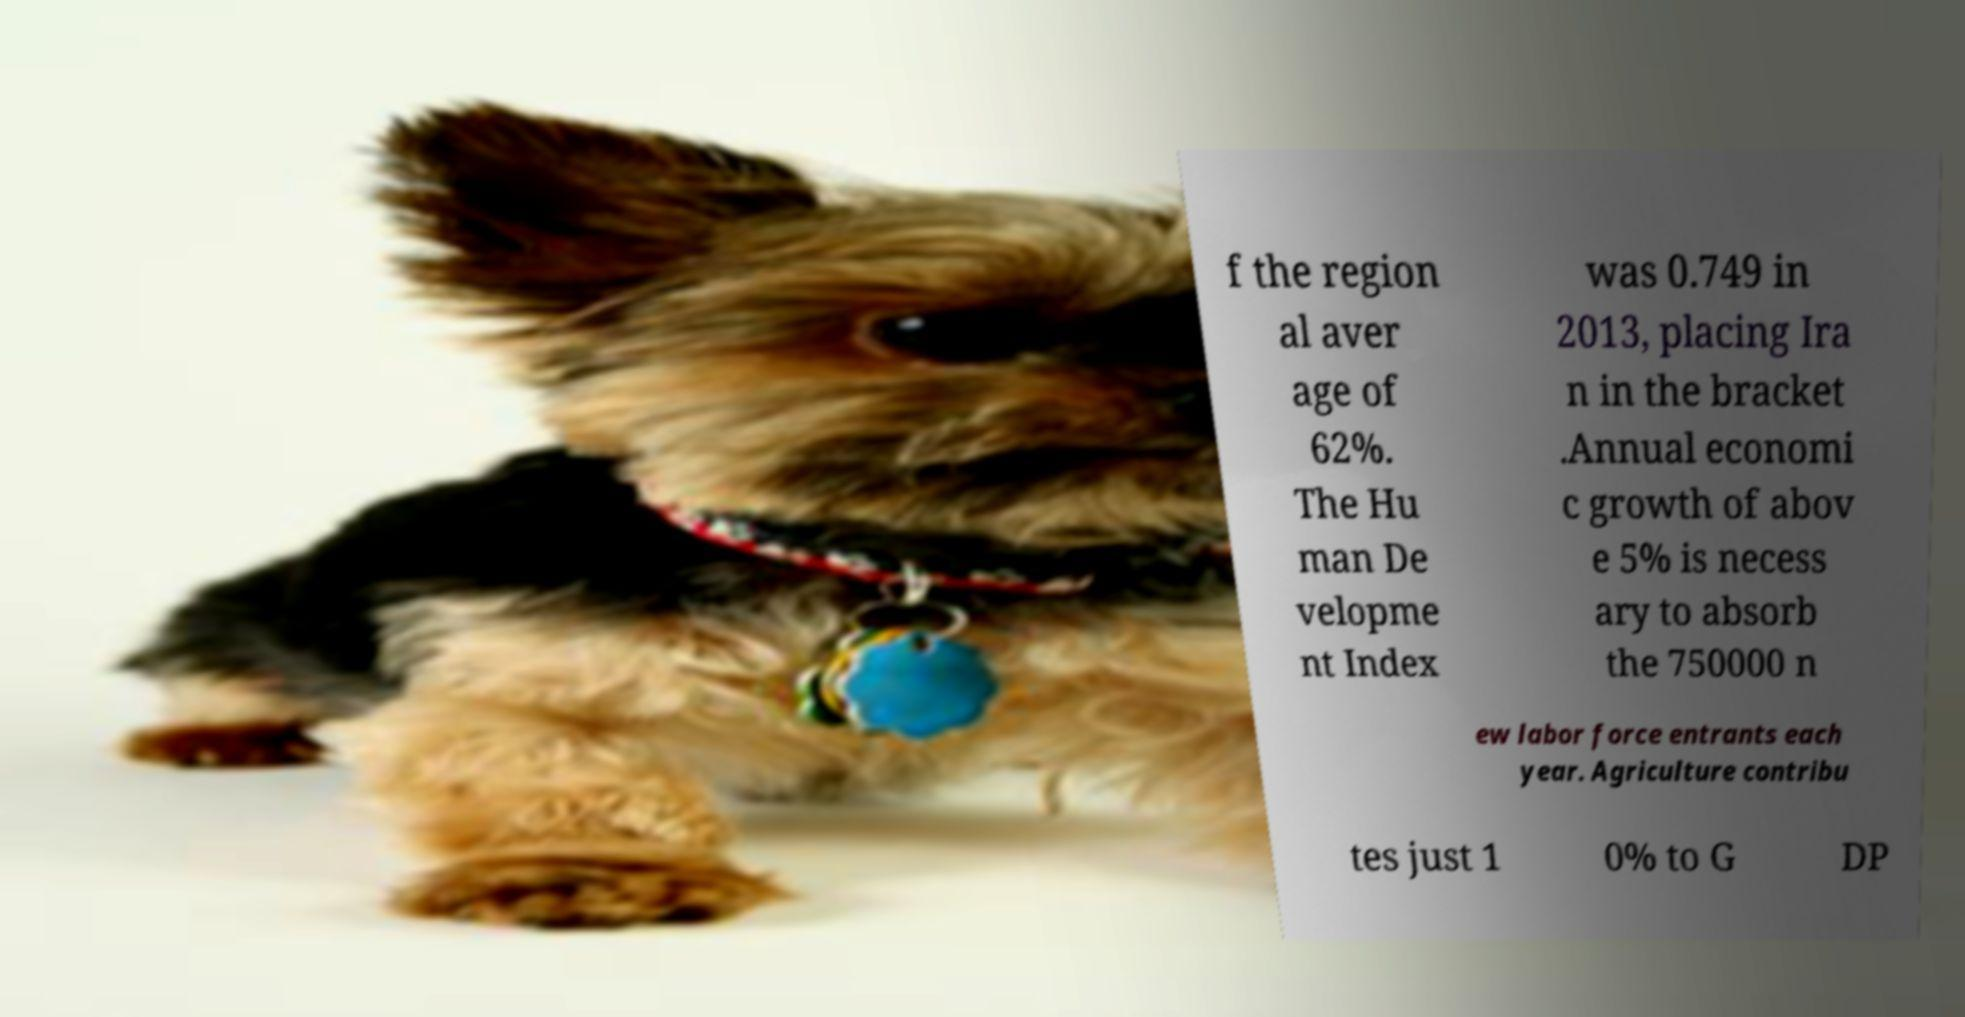There's text embedded in this image that I need extracted. Can you transcribe it verbatim? f the region al aver age of 62%. The Hu man De velopme nt Index was 0.749 in 2013, placing Ira n in the bracket .Annual economi c growth of abov e 5% is necess ary to absorb the 750000 n ew labor force entrants each year. Agriculture contribu tes just 1 0% to G DP 